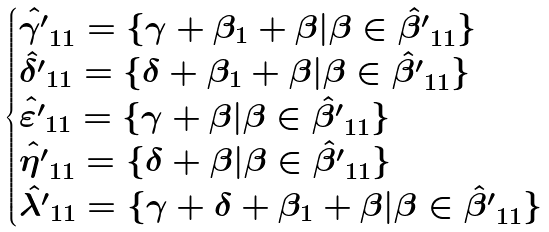<formula> <loc_0><loc_0><loc_500><loc_500>\begin{cases} \hat { \gamma ^ { \prime } } _ { 1 1 } = \{ \gamma + \beta _ { 1 } + \beta | \beta \in \hat { \beta ^ { \prime } } _ { 1 1 } \} \\ \hat { \delta ^ { \prime } } _ { 1 1 } = \{ \delta + \beta _ { 1 } + \beta | \beta \in \hat { \beta ^ { \prime } } _ { 1 1 } \} \\ \hat { \varepsilon ^ { \prime } } _ { 1 1 } = \{ \gamma + \beta | \beta \in \hat { \beta ^ { \prime } } _ { 1 1 } \} \\ \hat { \eta ^ { \prime } } _ { 1 1 } = \{ \delta + \beta | \beta \in \hat { \beta ^ { \prime } } _ { 1 1 } \} \\ \hat { \lambda ^ { \prime } } _ { 1 1 } = \{ \gamma + \delta + \beta _ { 1 } + \beta | \beta \in \hat { \beta ^ { \prime } } _ { 1 1 } \} \\ \end{cases}</formula> 